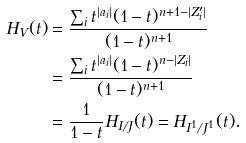<formula> <loc_0><loc_0><loc_500><loc_500>H _ { V } ( t ) & = \frac { \sum _ { i } t ^ { | a _ { i } | } ( 1 - t ) ^ { n + 1 - | Z ^ { \prime } _ { i } | } } { ( 1 - t ) ^ { n + 1 } } \\ & = \frac { \sum _ { i } t ^ { | a _ { i } | } ( 1 - t ) ^ { n - | Z _ { i } | } } { ( 1 - t ) ^ { n + 1 } } \\ & = \frac { 1 } { 1 - t } H _ { I / J } ( t ) = H _ { I ^ { 1 } / J ^ { 1 } } ( t ) .</formula> 